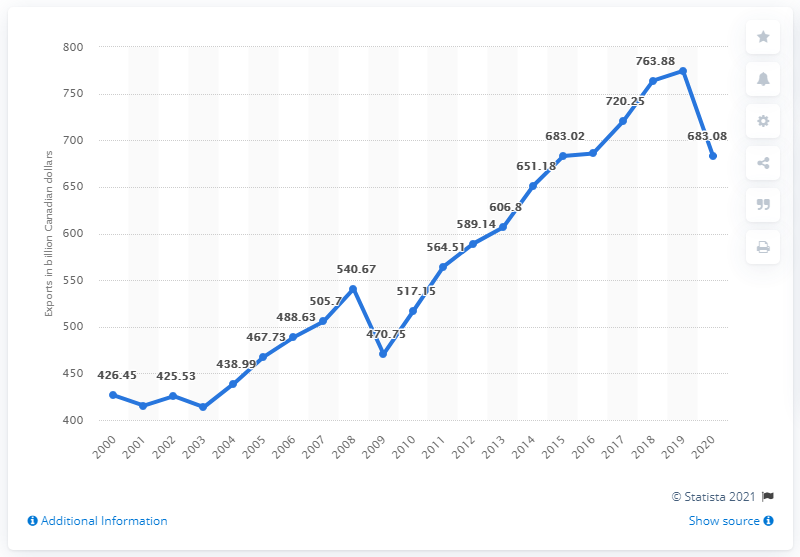Highlight a few significant elements in this photo. In 2020, Canada exported a total of 683.08 Canadian dollars worth of goods and services. In 2019, Canada's exports of goods and services totaled approximately CAD 774.37 billion. In what year did Canada's exports reach the same level as in 2020? The answer is 2015. 